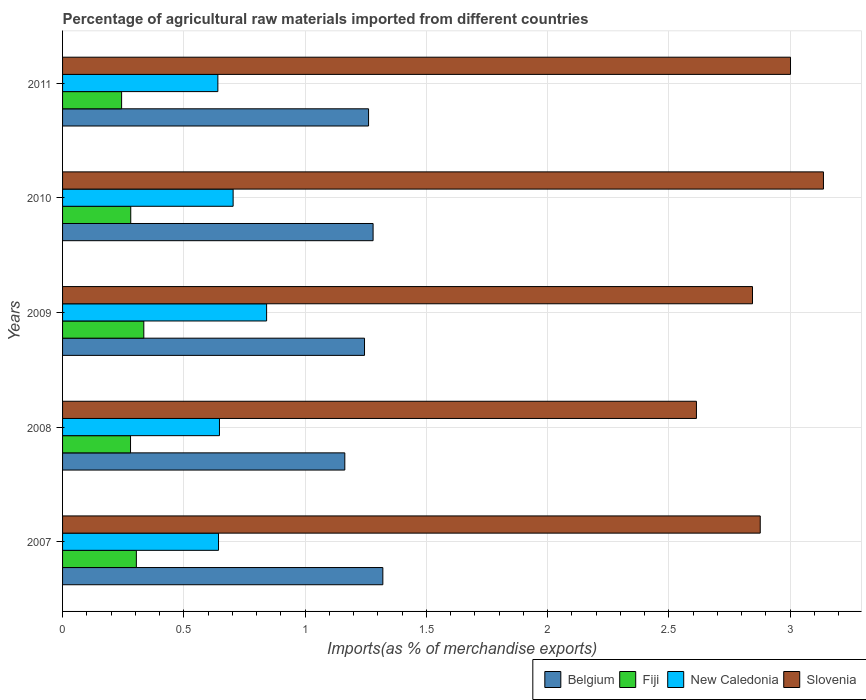How many different coloured bars are there?
Provide a succinct answer. 4. How many groups of bars are there?
Keep it short and to the point. 5. How many bars are there on the 5th tick from the bottom?
Your answer should be very brief. 4. In how many cases, is the number of bars for a given year not equal to the number of legend labels?
Provide a succinct answer. 0. What is the percentage of imports to different countries in Slovenia in 2010?
Ensure brevity in your answer.  3.14. Across all years, what is the maximum percentage of imports to different countries in Belgium?
Provide a short and direct response. 1.32. Across all years, what is the minimum percentage of imports to different countries in Belgium?
Give a very brief answer. 1.16. In which year was the percentage of imports to different countries in Slovenia minimum?
Provide a short and direct response. 2008. What is the total percentage of imports to different countries in Slovenia in the graph?
Ensure brevity in your answer.  14.47. What is the difference between the percentage of imports to different countries in New Caledonia in 2007 and that in 2009?
Offer a terse response. -0.2. What is the difference between the percentage of imports to different countries in Belgium in 2010 and the percentage of imports to different countries in Fiji in 2008?
Ensure brevity in your answer.  1. What is the average percentage of imports to different countries in Belgium per year?
Your answer should be very brief. 1.25. In the year 2011, what is the difference between the percentage of imports to different countries in Fiji and percentage of imports to different countries in New Caledonia?
Offer a terse response. -0.4. What is the ratio of the percentage of imports to different countries in Fiji in 2008 to that in 2009?
Your response must be concise. 0.84. Is the percentage of imports to different countries in Slovenia in 2008 less than that in 2010?
Ensure brevity in your answer.  Yes. Is the difference between the percentage of imports to different countries in Fiji in 2009 and 2010 greater than the difference between the percentage of imports to different countries in New Caledonia in 2009 and 2010?
Make the answer very short. No. What is the difference between the highest and the second highest percentage of imports to different countries in Belgium?
Your answer should be very brief. 0.04. What is the difference between the highest and the lowest percentage of imports to different countries in Slovenia?
Offer a very short reply. 0.52. Is the sum of the percentage of imports to different countries in New Caledonia in 2008 and 2011 greater than the maximum percentage of imports to different countries in Belgium across all years?
Give a very brief answer. No. What does the 3rd bar from the top in 2007 represents?
Offer a very short reply. Fiji. What does the 3rd bar from the bottom in 2009 represents?
Offer a terse response. New Caledonia. How many bars are there?
Provide a short and direct response. 20. Are all the bars in the graph horizontal?
Make the answer very short. Yes. How many years are there in the graph?
Provide a succinct answer. 5. What is the difference between two consecutive major ticks on the X-axis?
Your answer should be very brief. 0.5. Are the values on the major ticks of X-axis written in scientific E-notation?
Provide a succinct answer. No. Does the graph contain any zero values?
Your answer should be very brief. No. How many legend labels are there?
Offer a very short reply. 4. What is the title of the graph?
Offer a very short reply. Percentage of agricultural raw materials imported from different countries. What is the label or title of the X-axis?
Your answer should be compact. Imports(as % of merchandise exports). What is the label or title of the Y-axis?
Make the answer very short. Years. What is the Imports(as % of merchandise exports) of Belgium in 2007?
Provide a succinct answer. 1.32. What is the Imports(as % of merchandise exports) of Fiji in 2007?
Your answer should be compact. 0.3. What is the Imports(as % of merchandise exports) in New Caledonia in 2007?
Provide a succinct answer. 0.64. What is the Imports(as % of merchandise exports) of Slovenia in 2007?
Offer a terse response. 2.88. What is the Imports(as % of merchandise exports) of Belgium in 2008?
Make the answer very short. 1.16. What is the Imports(as % of merchandise exports) in Fiji in 2008?
Your answer should be very brief. 0.28. What is the Imports(as % of merchandise exports) of New Caledonia in 2008?
Your response must be concise. 0.65. What is the Imports(as % of merchandise exports) of Slovenia in 2008?
Give a very brief answer. 2.61. What is the Imports(as % of merchandise exports) of Belgium in 2009?
Your answer should be compact. 1.24. What is the Imports(as % of merchandise exports) in Fiji in 2009?
Offer a terse response. 0.33. What is the Imports(as % of merchandise exports) in New Caledonia in 2009?
Ensure brevity in your answer.  0.84. What is the Imports(as % of merchandise exports) in Slovenia in 2009?
Your response must be concise. 2.84. What is the Imports(as % of merchandise exports) in Belgium in 2010?
Your answer should be very brief. 1.28. What is the Imports(as % of merchandise exports) in Fiji in 2010?
Offer a very short reply. 0.28. What is the Imports(as % of merchandise exports) in New Caledonia in 2010?
Provide a short and direct response. 0.7. What is the Imports(as % of merchandise exports) in Slovenia in 2010?
Ensure brevity in your answer.  3.14. What is the Imports(as % of merchandise exports) in Belgium in 2011?
Your answer should be compact. 1.26. What is the Imports(as % of merchandise exports) in Fiji in 2011?
Offer a very short reply. 0.24. What is the Imports(as % of merchandise exports) in New Caledonia in 2011?
Offer a very short reply. 0.64. What is the Imports(as % of merchandise exports) in Slovenia in 2011?
Offer a very short reply. 3. Across all years, what is the maximum Imports(as % of merchandise exports) in Belgium?
Offer a terse response. 1.32. Across all years, what is the maximum Imports(as % of merchandise exports) in Fiji?
Provide a succinct answer. 0.33. Across all years, what is the maximum Imports(as % of merchandise exports) in New Caledonia?
Provide a succinct answer. 0.84. Across all years, what is the maximum Imports(as % of merchandise exports) of Slovenia?
Your answer should be compact. 3.14. Across all years, what is the minimum Imports(as % of merchandise exports) in Belgium?
Your answer should be compact. 1.16. Across all years, what is the minimum Imports(as % of merchandise exports) in Fiji?
Offer a terse response. 0.24. Across all years, what is the minimum Imports(as % of merchandise exports) in New Caledonia?
Provide a succinct answer. 0.64. Across all years, what is the minimum Imports(as % of merchandise exports) in Slovenia?
Provide a succinct answer. 2.61. What is the total Imports(as % of merchandise exports) of Belgium in the graph?
Offer a terse response. 6.27. What is the total Imports(as % of merchandise exports) of Fiji in the graph?
Offer a very short reply. 1.44. What is the total Imports(as % of merchandise exports) of New Caledonia in the graph?
Your answer should be compact. 3.47. What is the total Imports(as % of merchandise exports) in Slovenia in the graph?
Give a very brief answer. 14.47. What is the difference between the Imports(as % of merchandise exports) of Belgium in 2007 and that in 2008?
Your answer should be compact. 0.16. What is the difference between the Imports(as % of merchandise exports) of Fiji in 2007 and that in 2008?
Your answer should be compact. 0.02. What is the difference between the Imports(as % of merchandise exports) in New Caledonia in 2007 and that in 2008?
Offer a terse response. -0. What is the difference between the Imports(as % of merchandise exports) of Slovenia in 2007 and that in 2008?
Your answer should be compact. 0.26. What is the difference between the Imports(as % of merchandise exports) in Belgium in 2007 and that in 2009?
Offer a terse response. 0.08. What is the difference between the Imports(as % of merchandise exports) in Fiji in 2007 and that in 2009?
Provide a succinct answer. -0.03. What is the difference between the Imports(as % of merchandise exports) of New Caledonia in 2007 and that in 2009?
Keep it short and to the point. -0.2. What is the difference between the Imports(as % of merchandise exports) of Slovenia in 2007 and that in 2009?
Give a very brief answer. 0.03. What is the difference between the Imports(as % of merchandise exports) of Belgium in 2007 and that in 2010?
Keep it short and to the point. 0.04. What is the difference between the Imports(as % of merchandise exports) in Fiji in 2007 and that in 2010?
Your response must be concise. 0.02. What is the difference between the Imports(as % of merchandise exports) of New Caledonia in 2007 and that in 2010?
Provide a short and direct response. -0.06. What is the difference between the Imports(as % of merchandise exports) in Slovenia in 2007 and that in 2010?
Offer a very short reply. -0.26. What is the difference between the Imports(as % of merchandise exports) of Belgium in 2007 and that in 2011?
Your answer should be compact. 0.06. What is the difference between the Imports(as % of merchandise exports) of Fiji in 2007 and that in 2011?
Provide a short and direct response. 0.06. What is the difference between the Imports(as % of merchandise exports) in New Caledonia in 2007 and that in 2011?
Make the answer very short. 0. What is the difference between the Imports(as % of merchandise exports) in Slovenia in 2007 and that in 2011?
Provide a succinct answer. -0.12. What is the difference between the Imports(as % of merchandise exports) of Belgium in 2008 and that in 2009?
Give a very brief answer. -0.08. What is the difference between the Imports(as % of merchandise exports) in Fiji in 2008 and that in 2009?
Ensure brevity in your answer.  -0.05. What is the difference between the Imports(as % of merchandise exports) of New Caledonia in 2008 and that in 2009?
Keep it short and to the point. -0.19. What is the difference between the Imports(as % of merchandise exports) of Slovenia in 2008 and that in 2009?
Offer a terse response. -0.23. What is the difference between the Imports(as % of merchandise exports) of Belgium in 2008 and that in 2010?
Your answer should be compact. -0.12. What is the difference between the Imports(as % of merchandise exports) of Fiji in 2008 and that in 2010?
Provide a succinct answer. -0. What is the difference between the Imports(as % of merchandise exports) in New Caledonia in 2008 and that in 2010?
Your response must be concise. -0.06. What is the difference between the Imports(as % of merchandise exports) of Slovenia in 2008 and that in 2010?
Offer a terse response. -0.52. What is the difference between the Imports(as % of merchandise exports) of Belgium in 2008 and that in 2011?
Offer a terse response. -0.1. What is the difference between the Imports(as % of merchandise exports) in Fiji in 2008 and that in 2011?
Your answer should be very brief. 0.04. What is the difference between the Imports(as % of merchandise exports) in New Caledonia in 2008 and that in 2011?
Offer a terse response. 0.01. What is the difference between the Imports(as % of merchandise exports) of Slovenia in 2008 and that in 2011?
Keep it short and to the point. -0.39. What is the difference between the Imports(as % of merchandise exports) of Belgium in 2009 and that in 2010?
Ensure brevity in your answer.  -0.04. What is the difference between the Imports(as % of merchandise exports) in Fiji in 2009 and that in 2010?
Keep it short and to the point. 0.05. What is the difference between the Imports(as % of merchandise exports) in New Caledonia in 2009 and that in 2010?
Ensure brevity in your answer.  0.14. What is the difference between the Imports(as % of merchandise exports) of Slovenia in 2009 and that in 2010?
Ensure brevity in your answer.  -0.29. What is the difference between the Imports(as % of merchandise exports) in Belgium in 2009 and that in 2011?
Your answer should be very brief. -0.02. What is the difference between the Imports(as % of merchandise exports) of Fiji in 2009 and that in 2011?
Provide a succinct answer. 0.09. What is the difference between the Imports(as % of merchandise exports) of New Caledonia in 2009 and that in 2011?
Make the answer very short. 0.2. What is the difference between the Imports(as % of merchandise exports) of Slovenia in 2009 and that in 2011?
Make the answer very short. -0.16. What is the difference between the Imports(as % of merchandise exports) of Belgium in 2010 and that in 2011?
Your answer should be very brief. 0.02. What is the difference between the Imports(as % of merchandise exports) of Fiji in 2010 and that in 2011?
Your answer should be very brief. 0.04. What is the difference between the Imports(as % of merchandise exports) in New Caledonia in 2010 and that in 2011?
Give a very brief answer. 0.06. What is the difference between the Imports(as % of merchandise exports) of Slovenia in 2010 and that in 2011?
Your response must be concise. 0.14. What is the difference between the Imports(as % of merchandise exports) of Belgium in 2007 and the Imports(as % of merchandise exports) of Fiji in 2008?
Offer a terse response. 1.04. What is the difference between the Imports(as % of merchandise exports) of Belgium in 2007 and the Imports(as % of merchandise exports) of New Caledonia in 2008?
Your answer should be very brief. 0.67. What is the difference between the Imports(as % of merchandise exports) of Belgium in 2007 and the Imports(as % of merchandise exports) of Slovenia in 2008?
Make the answer very short. -1.29. What is the difference between the Imports(as % of merchandise exports) of Fiji in 2007 and the Imports(as % of merchandise exports) of New Caledonia in 2008?
Your answer should be compact. -0.34. What is the difference between the Imports(as % of merchandise exports) in Fiji in 2007 and the Imports(as % of merchandise exports) in Slovenia in 2008?
Keep it short and to the point. -2.31. What is the difference between the Imports(as % of merchandise exports) of New Caledonia in 2007 and the Imports(as % of merchandise exports) of Slovenia in 2008?
Make the answer very short. -1.97. What is the difference between the Imports(as % of merchandise exports) of Belgium in 2007 and the Imports(as % of merchandise exports) of Fiji in 2009?
Keep it short and to the point. 0.99. What is the difference between the Imports(as % of merchandise exports) of Belgium in 2007 and the Imports(as % of merchandise exports) of New Caledonia in 2009?
Offer a very short reply. 0.48. What is the difference between the Imports(as % of merchandise exports) of Belgium in 2007 and the Imports(as % of merchandise exports) of Slovenia in 2009?
Make the answer very short. -1.52. What is the difference between the Imports(as % of merchandise exports) in Fiji in 2007 and the Imports(as % of merchandise exports) in New Caledonia in 2009?
Keep it short and to the point. -0.54. What is the difference between the Imports(as % of merchandise exports) of Fiji in 2007 and the Imports(as % of merchandise exports) of Slovenia in 2009?
Make the answer very short. -2.54. What is the difference between the Imports(as % of merchandise exports) of New Caledonia in 2007 and the Imports(as % of merchandise exports) of Slovenia in 2009?
Provide a succinct answer. -2.2. What is the difference between the Imports(as % of merchandise exports) in Belgium in 2007 and the Imports(as % of merchandise exports) in Fiji in 2010?
Provide a succinct answer. 1.04. What is the difference between the Imports(as % of merchandise exports) of Belgium in 2007 and the Imports(as % of merchandise exports) of New Caledonia in 2010?
Offer a very short reply. 0.62. What is the difference between the Imports(as % of merchandise exports) in Belgium in 2007 and the Imports(as % of merchandise exports) in Slovenia in 2010?
Make the answer very short. -1.82. What is the difference between the Imports(as % of merchandise exports) in Fiji in 2007 and the Imports(as % of merchandise exports) in New Caledonia in 2010?
Offer a very short reply. -0.4. What is the difference between the Imports(as % of merchandise exports) of Fiji in 2007 and the Imports(as % of merchandise exports) of Slovenia in 2010?
Your response must be concise. -2.83. What is the difference between the Imports(as % of merchandise exports) of New Caledonia in 2007 and the Imports(as % of merchandise exports) of Slovenia in 2010?
Keep it short and to the point. -2.49. What is the difference between the Imports(as % of merchandise exports) of Belgium in 2007 and the Imports(as % of merchandise exports) of Fiji in 2011?
Offer a very short reply. 1.08. What is the difference between the Imports(as % of merchandise exports) of Belgium in 2007 and the Imports(as % of merchandise exports) of New Caledonia in 2011?
Keep it short and to the point. 0.68. What is the difference between the Imports(as % of merchandise exports) in Belgium in 2007 and the Imports(as % of merchandise exports) in Slovenia in 2011?
Give a very brief answer. -1.68. What is the difference between the Imports(as % of merchandise exports) in Fiji in 2007 and the Imports(as % of merchandise exports) in New Caledonia in 2011?
Your answer should be very brief. -0.34. What is the difference between the Imports(as % of merchandise exports) of Fiji in 2007 and the Imports(as % of merchandise exports) of Slovenia in 2011?
Give a very brief answer. -2.7. What is the difference between the Imports(as % of merchandise exports) of New Caledonia in 2007 and the Imports(as % of merchandise exports) of Slovenia in 2011?
Your answer should be very brief. -2.36. What is the difference between the Imports(as % of merchandise exports) of Belgium in 2008 and the Imports(as % of merchandise exports) of Fiji in 2009?
Keep it short and to the point. 0.83. What is the difference between the Imports(as % of merchandise exports) of Belgium in 2008 and the Imports(as % of merchandise exports) of New Caledonia in 2009?
Offer a terse response. 0.32. What is the difference between the Imports(as % of merchandise exports) in Belgium in 2008 and the Imports(as % of merchandise exports) in Slovenia in 2009?
Your answer should be compact. -1.68. What is the difference between the Imports(as % of merchandise exports) in Fiji in 2008 and the Imports(as % of merchandise exports) in New Caledonia in 2009?
Your answer should be compact. -0.56. What is the difference between the Imports(as % of merchandise exports) of Fiji in 2008 and the Imports(as % of merchandise exports) of Slovenia in 2009?
Your response must be concise. -2.56. What is the difference between the Imports(as % of merchandise exports) in New Caledonia in 2008 and the Imports(as % of merchandise exports) in Slovenia in 2009?
Your answer should be compact. -2.2. What is the difference between the Imports(as % of merchandise exports) in Belgium in 2008 and the Imports(as % of merchandise exports) in Fiji in 2010?
Your answer should be very brief. 0.88. What is the difference between the Imports(as % of merchandise exports) in Belgium in 2008 and the Imports(as % of merchandise exports) in New Caledonia in 2010?
Provide a short and direct response. 0.46. What is the difference between the Imports(as % of merchandise exports) in Belgium in 2008 and the Imports(as % of merchandise exports) in Slovenia in 2010?
Offer a very short reply. -1.97. What is the difference between the Imports(as % of merchandise exports) in Fiji in 2008 and the Imports(as % of merchandise exports) in New Caledonia in 2010?
Keep it short and to the point. -0.42. What is the difference between the Imports(as % of merchandise exports) in Fiji in 2008 and the Imports(as % of merchandise exports) in Slovenia in 2010?
Give a very brief answer. -2.86. What is the difference between the Imports(as % of merchandise exports) in New Caledonia in 2008 and the Imports(as % of merchandise exports) in Slovenia in 2010?
Your answer should be very brief. -2.49. What is the difference between the Imports(as % of merchandise exports) in Belgium in 2008 and the Imports(as % of merchandise exports) in Fiji in 2011?
Keep it short and to the point. 0.92. What is the difference between the Imports(as % of merchandise exports) in Belgium in 2008 and the Imports(as % of merchandise exports) in New Caledonia in 2011?
Your answer should be compact. 0.52. What is the difference between the Imports(as % of merchandise exports) in Belgium in 2008 and the Imports(as % of merchandise exports) in Slovenia in 2011?
Your answer should be compact. -1.84. What is the difference between the Imports(as % of merchandise exports) of Fiji in 2008 and the Imports(as % of merchandise exports) of New Caledonia in 2011?
Offer a very short reply. -0.36. What is the difference between the Imports(as % of merchandise exports) of Fiji in 2008 and the Imports(as % of merchandise exports) of Slovenia in 2011?
Offer a terse response. -2.72. What is the difference between the Imports(as % of merchandise exports) in New Caledonia in 2008 and the Imports(as % of merchandise exports) in Slovenia in 2011?
Your answer should be compact. -2.35. What is the difference between the Imports(as % of merchandise exports) of Belgium in 2009 and the Imports(as % of merchandise exports) of Fiji in 2010?
Your response must be concise. 0.96. What is the difference between the Imports(as % of merchandise exports) of Belgium in 2009 and the Imports(as % of merchandise exports) of New Caledonia in 2010?
Provide a succinct answer. 0.54. What is the difference between the Imports(as % of merchandise exports) in Belgium in 2009 and the Imports(as % of merchandise exports) in Slovenia in 2010?
Your answer should be compact. -1.89. What is the difference between the Imports(as % of merchandise exports) of Fiji in 2009 and the Imports(as % of merchandise exports) of New Caledonia in 2010?
Your answer should be compact. -0.37. What is the difference between the Imports(as % of merchandise exports) in Fiji in 2009 and the Imports(as % of merchandise exports) in Slovenia in 2010?
Provide a succinct answer. -2.8. What is the difference between the Imports(as % of merchandise exports) in New Caledonia in 2009 and the Imports(as % of merchandise exports) in Slovenia in 2010?
Your response must be concise. -2.3. What is the difference between the Imports(as % of merchandise exports) in Belgium in 2009 and the Imports(as % of merchandise exports) in New Caledonia in 2011?
Offer a terse response. 0.6. What is the difference between the Imports(as % of merchandise exports) in Belgium in 2009 and the Imports(as % of merchandise exports) in Slovenia in 2011?
Your answer should be compact. -1.76. What is the difference between the Imports(as % of merchandise exports) of Fiji in 2009 and the Imports(as % of merchandise exports) of New Caledonia in 2011?
Provide a short and direct response. -0.31. What is the difference between the Imports(as % of merchandise exports) in Fiji in 2009 and the Imports(as % of merchandise exports) in Slovenia in 2011?
Provide a succinct answer. -2.67. What is the difference between the Imports(as % of merchandise exports) of New Caledonia in 2009 and the Imports(as % of merchandise exports) of Slovenia in 2011?
Your answer should be compact. -2.16. What is the difference between the Imports(as % of merchandise exports) in Belgium in 2010 and the Imports(as % of merchandise exports) in Fiji in 2011?
Give a very brief answer. 1.04. What is the difference between the Imports(as % of merchandise exports) in Belgium in 2010 and the Imports(as % of merchandise exports) in New Caledonia in 2011?
Your response must be concise. 0.64. What is the difference between the Imports(as % of merchandise exports) of Belgium in 2010 and the Imports(as % of merchandise exports) of Slovenia in 2011?
Give a very brief answer. -1.72. What is the difference between the Imports(as % of merchandise exports) in Fiji in 2010 and the Imports(as % of merchandise exports) in New Caledonia in 2011?
Offer a very short reply. -0.36. What is the difference between the Imports(as % of merchandise exports) in Fiji in 2010 and the Imports(as % of merchandise exports) in Slovenia in 2011?
Ensure brevity in your answer.  -2.72. What is the difference between the Imports(as % of merchandise exports) of New Caledonia in 2010 and the Imports(as % of merchandise exports) of Slovenia in 2011?
Keep it short and to the point. -2.3. What is the average Imports(as % of merchandise exports) of Belgium per year?
Give a very brief answer. 1.25. What is the average Imports(as % of merchandise exports) in Fiji per year?
Your answer should be very brief. 0.29. What is the average Imports(as % of merchandise exports) in New Caledonia per year?
Your answer should be compact. 0.69. What is the average Imports(as % of merchandise exports) of Slovenia per year?
Ensure brevity in your answer.  2.89. In the year 2007, what is the difference between the Imports(as % of merchandise exports) of Belgium and Imports(as % of merchandise exports) of Fiji?
Keep it short and to the point. 1.02. In the year 2007, what is the difference between the Imports(as % of merchandise exports) of Belgium and Imports(as % of merchandise exports) of New Caledonia?
Offer a very short reply. 0.68. In the year 2007, what is the difference between the Imports(as % of merchandise exports) in Belgium and Imports(as % of merchandise exports) in Slovenia?
Ensure brevity in your answer.  -1.56. In the year 2007, what is the difference between the Imports(as % of merchandise exports) in Fiji and Imports(as % of merchandise exports) in New Caledonia?
Make the answer very short. -0.34. In the year 2007, what is the difference between the Imports(as % of merchandise exports) in Fiji and Imports(as % of merchandise exports) in Slovenia?
Give a very brief answer. -2.57. In the year 2007, what is the difference between the Imports(as % of merchandise exports) in New Caledonia and Imports(as % of merchandise exports) in Slovenia?
Provide a succinct answer. -2.23. In the year 2008, what is the difference between the Imports(as % of merchandise exports) in Belgium and Imports(as % of merchandise exports) in Fiji?
Your answer should be compact. 0.88. In the year 2008, what is the difference between the Imports(as % of merchandise exports) in Belgium and Imports(as % of merchandise exports) in New Caledonia?
Your answer should be compact. 0.52. In the year 2008, what is the difference between the Imports(as % of merchandise exports) of Belgium and Imports(as % of merchandise exports) of Slovenia?
Give a very brief answer. -1.45. In the year 2008, what is the difference between the Imports(as % of merchandise exports) in Fiji and Imports(as % of merchandise exports) in New Caledonia?
Offer a terse response. -0.37. In the year 2008, what is the difference between the Imports(as % of merchandise exports) of Fiji and Imports(as % of merchandise exports) of Slovenia?
Make the answer very short. -2.33. In the year 2008, what is the difference between the Imports(as % of merchandise exports) in New Caledonia and Imports(as % of merchandise exports) in Slovenia?
Give a very brief answer. -1.97. In the year 2009, what is the difference between the Imports(as % of merchandise exports) in Belgium and Imports(as % of merchandise exports) in Fiji?
Your answer should be compact. 0.91. In the year 2009, what is the difference between the Imports(as % of merchandise exports) in Belgium and Imports(as % of merchandise exports) in New Caledonia?
Provide a short and direct response. 0.4. In the year 2009, what is the difference between the Imports(as % of merchandise exports) of Belgium and Imports(as % of merchandise exports) of Slovenia?
Offer a very short reply. -1.6. In the year 2009, what is the difference between the Imports(as % of merchandise exports) of Fiji and Imports(as % of merchandise exports) of New Caledonia?
Your answer should be very brief. -0.51. In the year 2009, what is the difference between the Imports(as % of merchandise exports) of Fiji and Imports(as % of merchandise exports) of Slovenia?
Your answer should be very brief. -2.51. In the year 2009, what is the difference between the Imports(as % of merchandise exports) in New Caledonia and Imports(as % of merchandise exports) in Slovenia?
Offer a very short reply. -2. In the year 2010, what is the difference between the Imports(as % of merchandise exports) of Belgium and Imports(as % of merchandise exports) of New Caledonia?
Offer a terse response. 0.58. In the year 2010, what is the difference between the Imports(as % of merchandise exports) of Belgium and Imports(as % of merchandise exports) of Slovenia?
Make the answer very short. -1.86. In the year 2010, what is the difference between the Imports(as % of merchandise exports) in Fiji and Imports(as % of merchandise exports) in New Caledonia?
Keep it short and to the point. -0.42. In the year 2010, what is the difference between the Imports(as % of merchandise exports) in Fiji and Imports(as % of merchandise exports) in Slovenia?
Your answer should be very brief. -2.86. In the year 2010, what is the difference between the Imports(as % of merchandise exports) in New Caledonia and Imports(as % of merchandise exports) in Slovenia?
Your response must be concise. -2.43. In the year 2011, what is the difference between the Imports(as % of merchandise exports) in Belgium and Imports(as % of merchandise exports) in Fiji?
Provide a succinct answer. 1.02. In the year 2011, what is the difference between the Imports(as % of merchandise exports) of Belgium and Imports(as % of merchandise exports) of New Caledonia?
Your answer should be very brief. 0.62. In the year 2011, what is the difference between the Imports(as % of merchandise exports) in Belgium and Imports(as % of merchandise exports) in Slovenia?
Provide a succinct answer. -1.74. In the year 2011, what is the difference between the Imports(as % of merchandise exports) in Fiji and Imports(as % of merchandise exports) in New Caledonia?
Keep it short and to the point. -0.4. In the year 2011, what is the difference between the Imports(as % of merchandise exports) of Fiji and Imports(as % of merchandise exports) of Slovenia?
Provide a short and direct response. -2.76. In the year 2011, what is the difference between the Imports(as % of merchandise exports) of New Caledonia and Imports(as % of merchandise exports) of Slovenia?
Offer a terse response. -2.36. What is the ratio of the Imports(as % of merchandise exports) of Belgium in 2007 to that in 2008?
Your answer should be compact. 1.13. What is the ratio of the Imports(as % of merchandise exports) of Fiji in 2007 to that in 2008?
Offer a terse response. 1.09. What is the ratio of the Imports(as % of merchandise exports) in New Caledonia in 2007 to that in 2008?
Your answer should be very brief. 0.99. What is the ratio of the Imports(as % of merchandise exports) in Slovenia in 2007 to that in 2008?
Your answer should be very brief. 1.1. What is the ratio of the Imports(as % of merchandise exports) in Belgium in 2007 to that in 2009?
Offer a very short reply. 1.06. What is the ratio of the Imports(as % of merchandise exports) of Fiji in 2007 to that in 2009?
Your answer should be very brief. 0.91. What is the ratio of the Imports(as % of merchandise exports) in New Caledonia in 2007 to that in 2009?
Make the answer very short. 0.76. What is the ratio of the Imports(as % of merchandise exports) of Slovenia in 2007 to that in 2009?
Offer a very short reply. 1.01. What is the ratio of the Imports(as % of merchandise exports) of Belgium in 2007 to that in 2010?
Offer a very short reply. 1.03. What is the ratio of the Imports(as % of merchandise exports) of Fiji in 2007 to that in 2010?
Make the answer very short. 1.08. What is the ratio of the Imports(as % of merchandise exports) in New Caledonia in 2007 to that in 2010?
Your response must be concise. 0.91. What is the ratio of the Imports(as % of merchandise exports) in Slovenia in 2007 to that in 2010?
Offer a very short reply. 0.92. What is the ratio of the Imports(as % of merchandise exports) of Belgium in 2007 to that in 2011?
Offer a very short reply. 1.05. What is the ratio of the Imports(as % of merchandise exports) in Fiji in 2007 to that in 2011?
Your response must be concise. 1.25. What is the ratio of the Imports(as % of merchandise exports) in New Caledonia in 2007 to that in 2011?
Offer a terse response. 1. What is the ratio of the Imports(as % of merchandise exports) of Slovenia in 2007 to that in 2011?
Make the answer very short. 0.96. What is the ratio of the Imports(as % of merchandise exports) in Belgium in 2008 to that in 2009?
Offer a terse response. 0.93. What is the ratio of the Imports(as % of merchandise exports) in Fiji in 2008 to that in 2009?
Offer a very short reply. 0.84. What is the ratio of the Imports(as % of merchandise exports) of New Caledonia in 2008 to that in 2009?
Give a very brief answer. 0.77. What is the ratio of the Imports(as % of merchandise exports) of Slovenia in 2008 to that in 2009?
Give a very brief answer. 0.92. What is the ratio of the Imports(as % of merchandise exports) in Belgium in 2008 to that in 2010?
Provide a short and direct response. 0.91. What is the ratio of the Imports(as % of merchandise exports) in New Caledonia in 2008 to that in 2010?
Ensure brevity in your answer.  0.92. What is the ratio of the Imports(as % of merchandise exports) in Slovenia in 2008 to that in 2010?
Make the answer very short. 0.83. What is the ratio of the Imports(as % of merchandise exports) in Belgium in 2008 to that in 2011?
Your response must be concise. 0.92. What is the ratio of the Imports(as % of merchandise exports) in Fiji in 2008 to that in 2011?
Offer a terse response. 1.15. What is the ratio of the Imports(as % of merchandise exports) of New Caledonia in 2008 to that in 2011?
Give a very brief answer. 1.01. What is the ratio of the Imports(as % of merchandise exports) in Slovenia in 2008 to that in 2011?
Your answer should be very brief. 0.87. What is the ratio of the Imports(as % of merchandise exports) in Belgium in 2009 to that in 2010?
Keep it short and to the point. 0.97. What is the ratio of the Imports(as % of merchandise exports) of Fiji in 2009 to that in 2010?
Your response must be concise. 1.19. What is the ratio of the Imports(as % of merchandise exports) of New Caledonia in 2009 to that in 2010?
Keep it short and to the point. 1.2. What is the ratio of the Imports(as % of merchandise exports) in Slovenia in 2009 to that in 2010?
Offer a terse response. 0.91. What is the ratio of the Imports(as % of merchandise exports) in Fiji in 2009 to that in 2011?
Your response must be concise. 1.38. What is the ratio of the Imports(as % of merchandise exports) of New Caledonia in 2009 to that in 2011?
Offer a terse response. 1.31. What is the ratio of the Imports(as % of merchandise exports) of Slovenia in 2009 to that in 2011?
Ensure brevity in your answer.  0.95. What is the ratio of the Imports(as % of merchandise exports) in Belgium in 2010 to that in 2011?
Offer a very short reply. 1.01. What is the ratio of the Imports(as % of merchandise exports) in Fiji in 2010 to that in 2011?
Provide a short and direct response. 1.15. What is the ratio of the Imports(as % of merchandise exports) of New Caledonia in 2010 to that in 2011?
Make the answer very short. 1.1. What is the ratio of the Imports(as % of merchandise exports) in Slovenia in 2010 to that in 2011?
Your answer should be compact. 1.05. What is the difference between the highest and the second highest Imports(as % of merchandise exports) in Belgium?
Your answer should be compact. 0.04. What is the difference between the highest and the second highest Imports(as % of merchandise exports) of Fiji?
Make the answer very short. 0.03. What is the difference between the highest and the second highest Imports(as % of merchandise exports) of New Caledonia?
Offer a very short reply. 0.14. What is the difference between the highest and the second highest Imports(as % of merchandise exports) in Slovenia?
Your response must be concise. 0.14. What is the difference between the highest and the lowest Imports(as % of merchandise exports) of Belgium?
Your answer should be compact. 0.16. What is the difference between the highest and the lowest Imports(as % of merchandise exports) in Fiji?
Give a very brief answer. 0.09. What is the difference between the highest and the lowest Imports(as % of merchandise exports) of New Caledonia?
Offer a very short reply. 0.2. What is the difference between the highest and the lowest Imports(as % of merchandise exports) in Slovenia?
Your answer should be very brief. 0.52. 